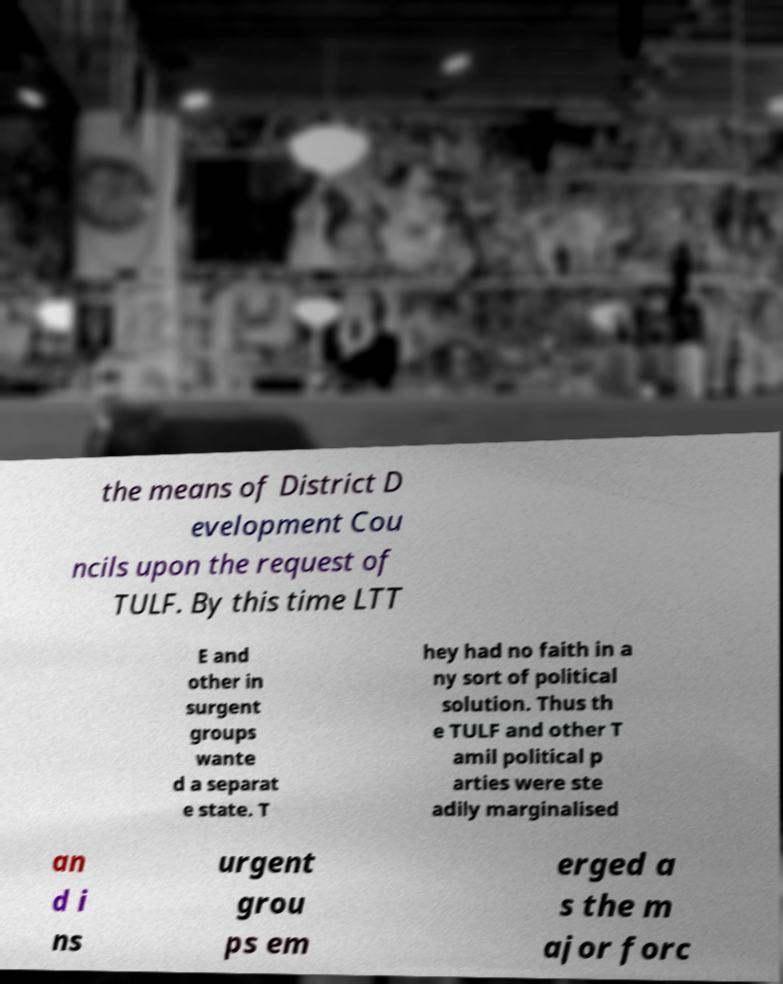Please identify and transcribe the text found in this image. the means of District D evelopment Cou ncils upon the request of TULF. By this time LTT E and other in surgent groups wante d a separat e state. T hey had no faith in a ny sort of political solution. Thus th e TULF and other T amil political p arties were ste adily marginalised an d i ns urgent grou ps em erged a s the m ajor forc 